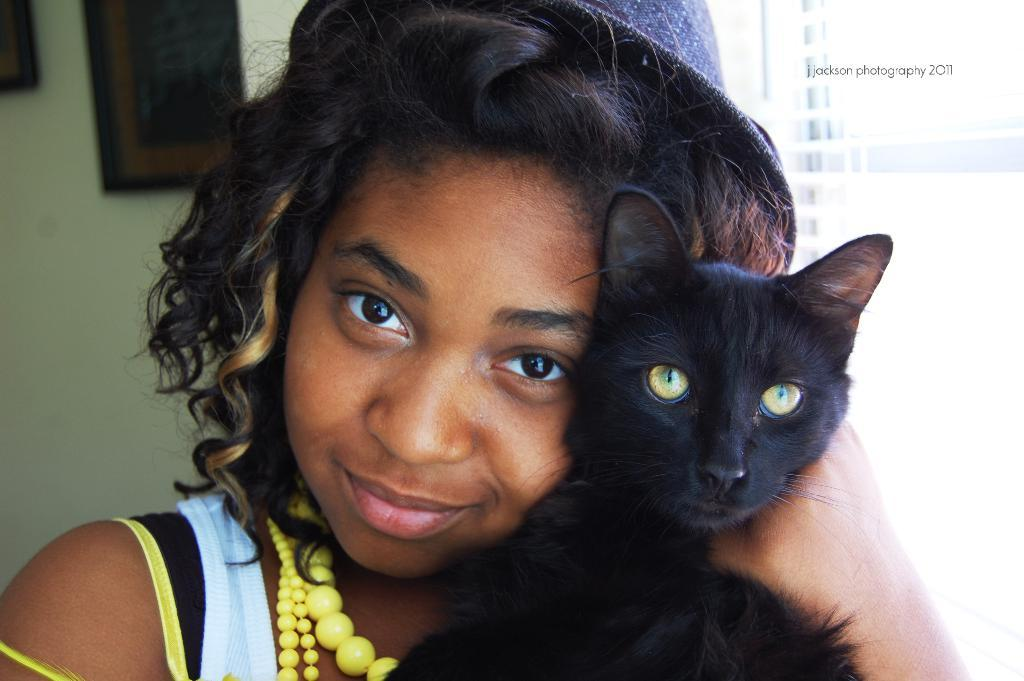What is present in the background of the image? There is a wall in the image. Can you describe the person in the image? There is a woman in the image. What is the woman holding in the image? The woman is holding a black color cat. What type of game is being played in the alley in the image? There is no alley or game present in the image; it features a woman holding a black color cat in front of a wall. What role does the woman play in the society in the image? The image does not provide any information about the woman's role in society. 